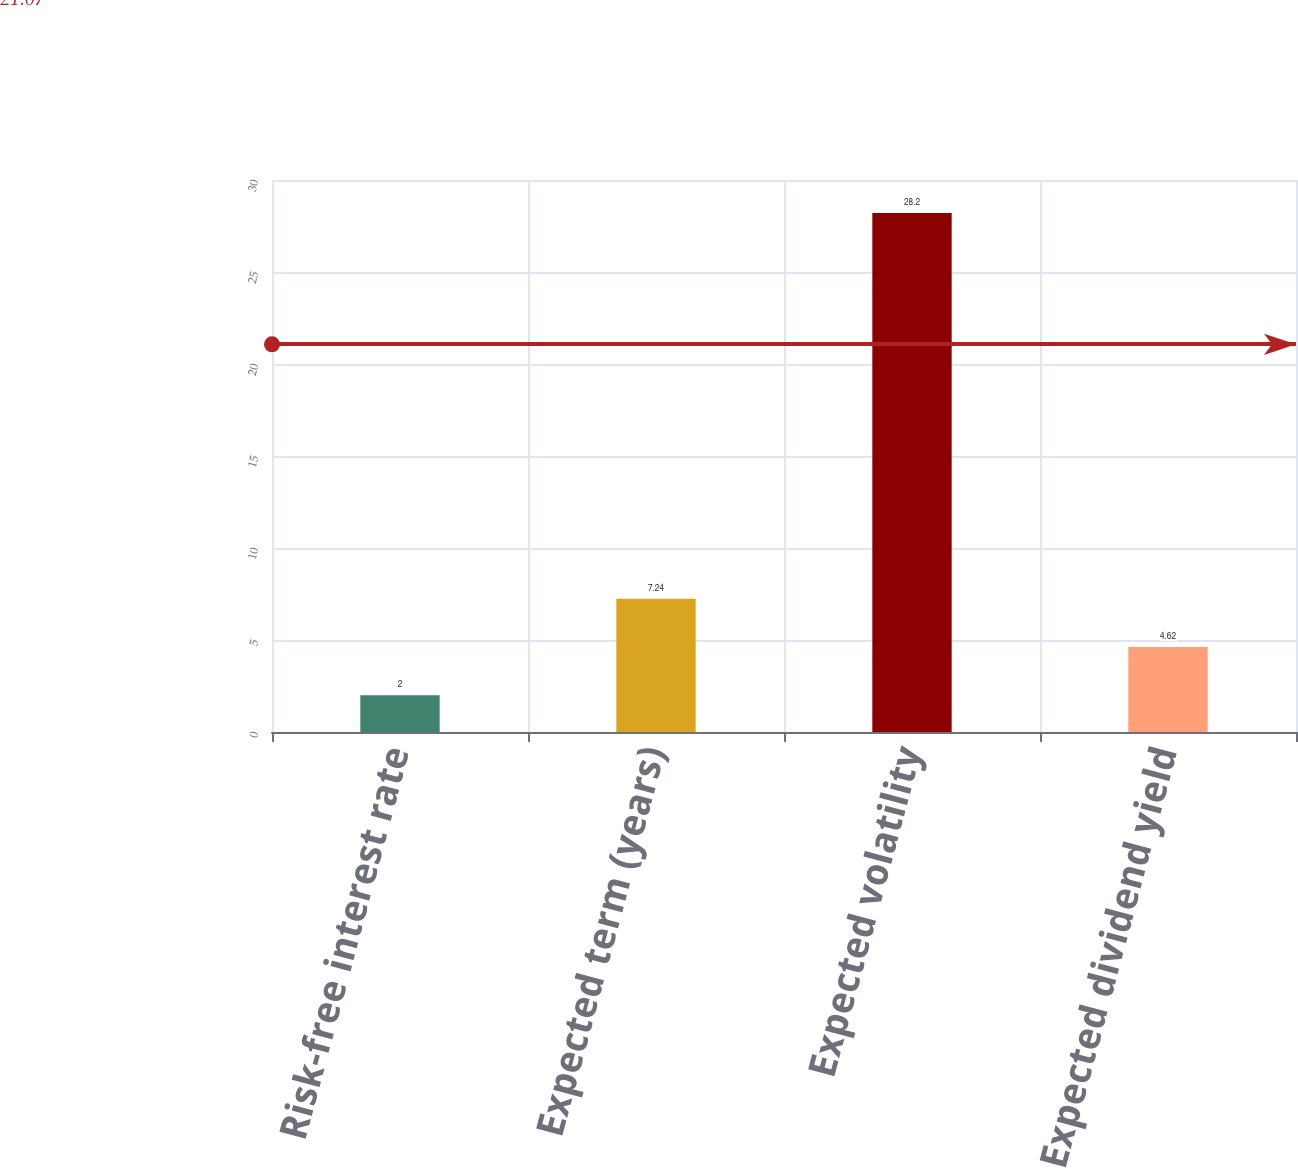Convert chart to OTSL. <chart><loc_0><loc_0><loc_500><loc_500><bar_chart><fcel>Risk-free interest rate<fcel>Expected term (years)<fcel>Expected volatility<fcel>Expected dividend yield<nl><fcel>2<fcel>7.24<fcel>28.2<fcel>4.62<nl></chart> 